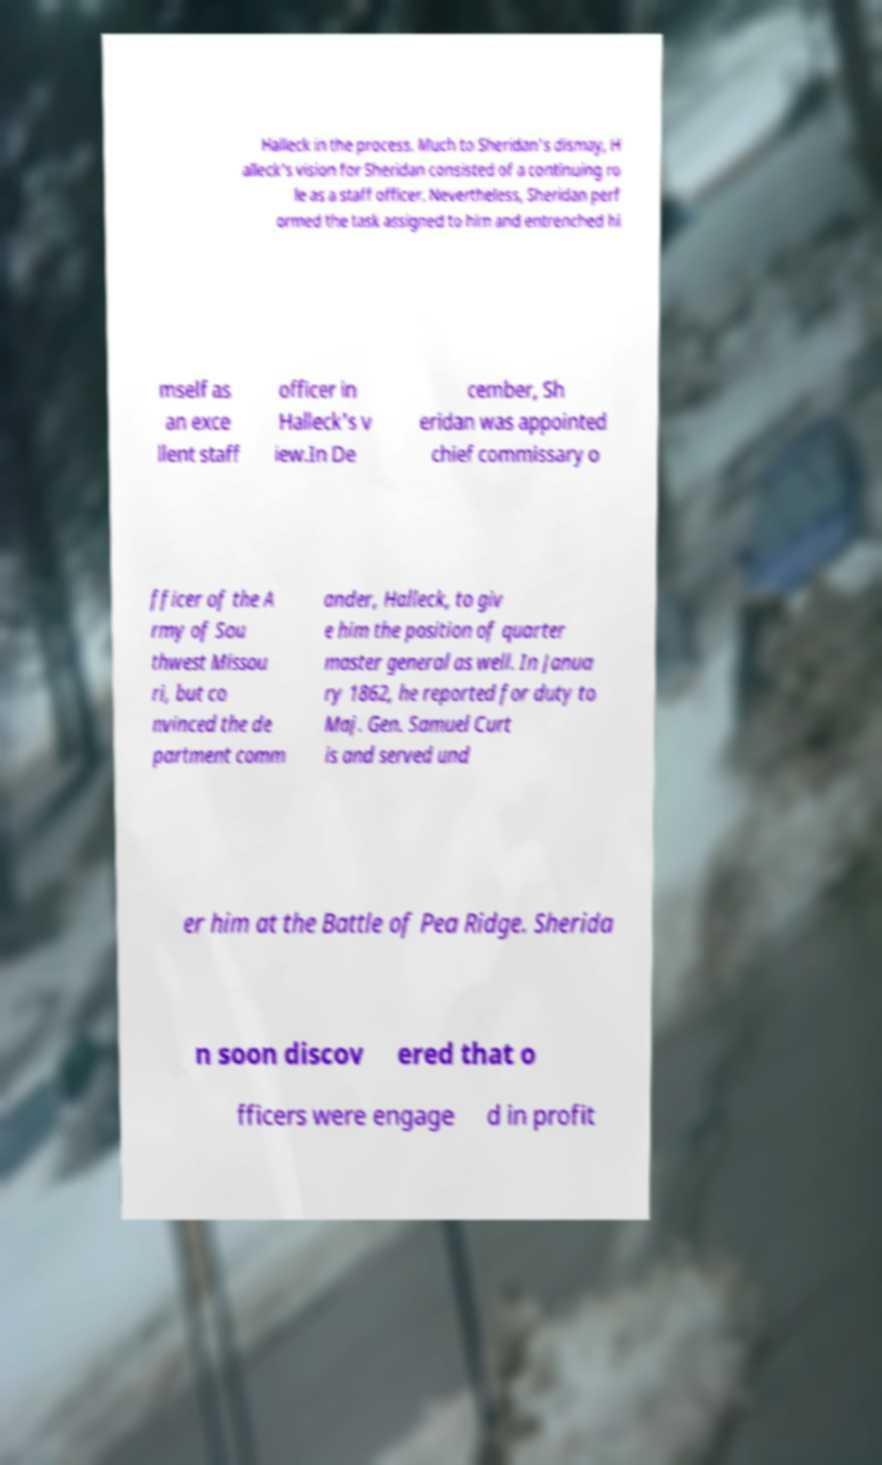Could you assist in decoding the text presented in this image and type it out clearly? Halleck in the process. Much to Sheridan's dismay, H alleck's vision for Sheridan consisted of a continuing ro le as a staff officer. Nevertheless, Sheridan perf ormed the task assigned to him and entrenched hi mself as an exce llent staff officer in Halleck's v iew.In De cember, Sh eridan was appointed chief commissary o fficer of the A rmy of Sou thwest Missou ri, but co nvinced the de partment comm ander, Halleck, to giv e him the position of quarter master general as well. In Janua ry 1862, he reported for duty to Maj. Gen. Samuel Curt is and served und er him at the Battle of Pea Ridge. Sherida n soon discov ered that o fficers were engage d in profit 